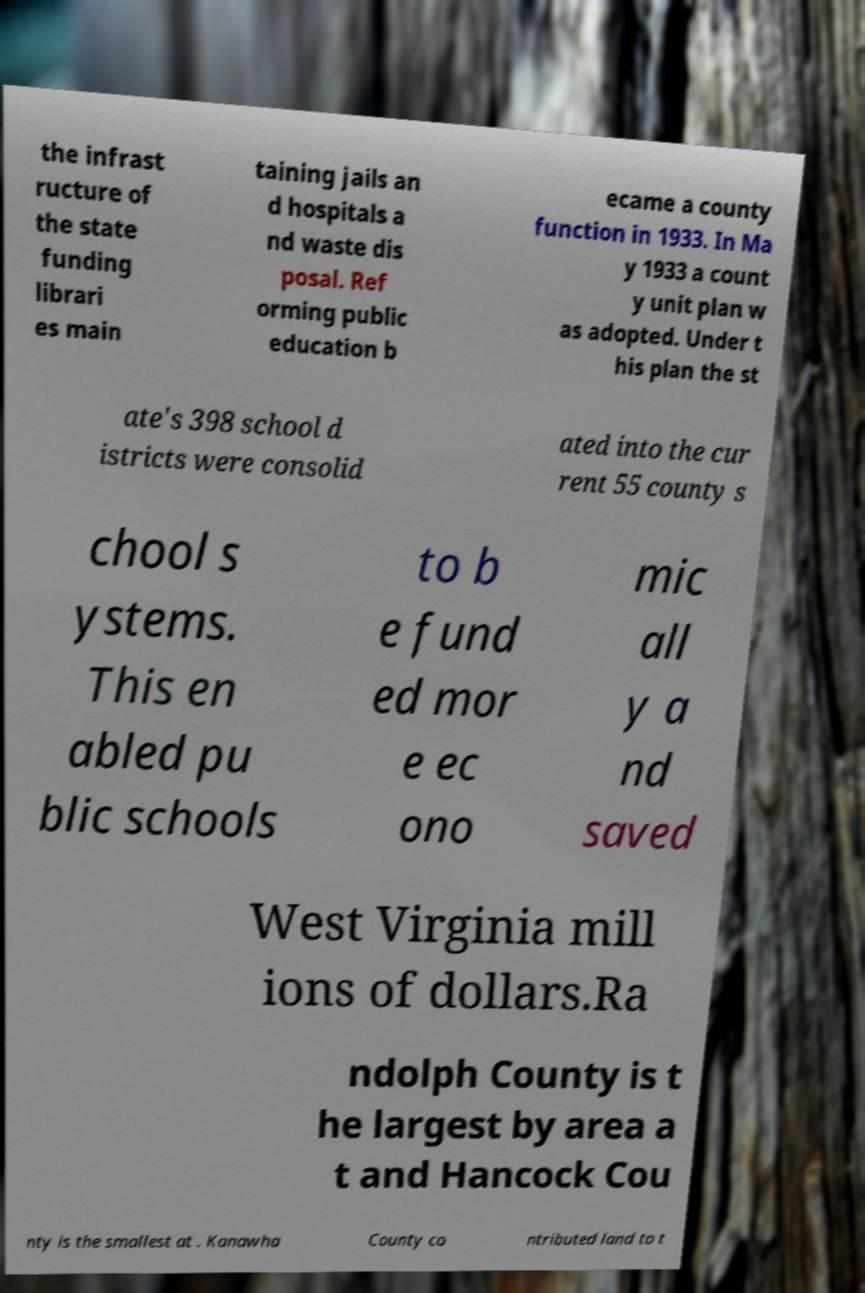For documentation purposes, I need the text within this image transcribed. Could you provide that? the infrast ructure of the state funding librari es main taining jails an d hospitals a nd waste dis posal. Ref orming public education b ecame a county function in 1933. In Ma y 1933 a count y unit plan w as adopted. Under t his plan the st ate's 398 school d istricts were consolid ated into the cur rent 55 county s chool s ystems. This en abled pu blic schools to b e fund ed mor e ec ono mic all y a nd saved West Virginia mill ions of dollars.Ra ndolph County is t he largest by area a t and Hancock Cou nty is the smallest at . Kanawha County co ntributed land to t 